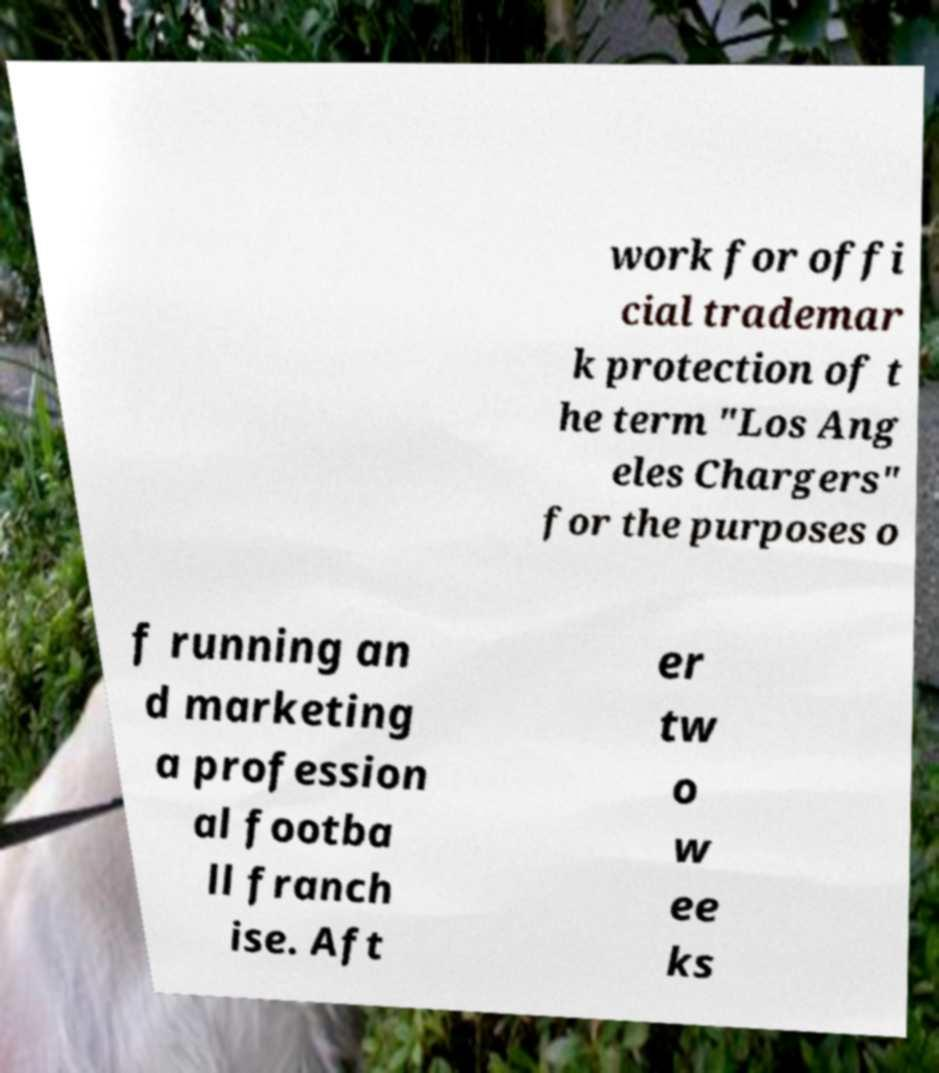For documentation purposes, I need the text within this image transcribed. Could you provide that? work for offi cial trademar k protection of t he term "Los Ang eles Chargers" for the purposes o f running an d marketing a profession al footba ll franch ise. Aft er tw o w ee ks 